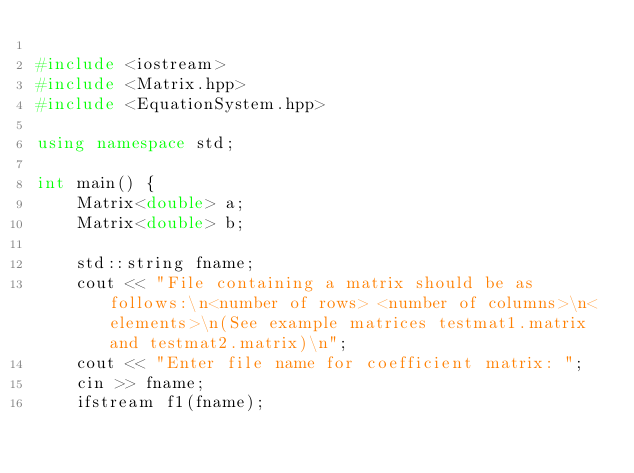<code> <loc_0><loc_0><loc_500><loc_500><_C++_>
#include <iostream>
#include <Matrix.hpp>
#include <EquationSystem.hpp>

using namespace std;

int main() {
	Matrix<double> a;
	Matrix<double> b;

	std::string fname;
	cout << "File containing a matrix should be as follows:\n<number of rows> <number of columns>\n<elements>\n(See example matrices testmat1.matrix and testmat2.matrix)\n";
	cout << "Enter file name for coefficient matrix: ";
	cin >> fname;
	ifstream f1(fname);</code> 